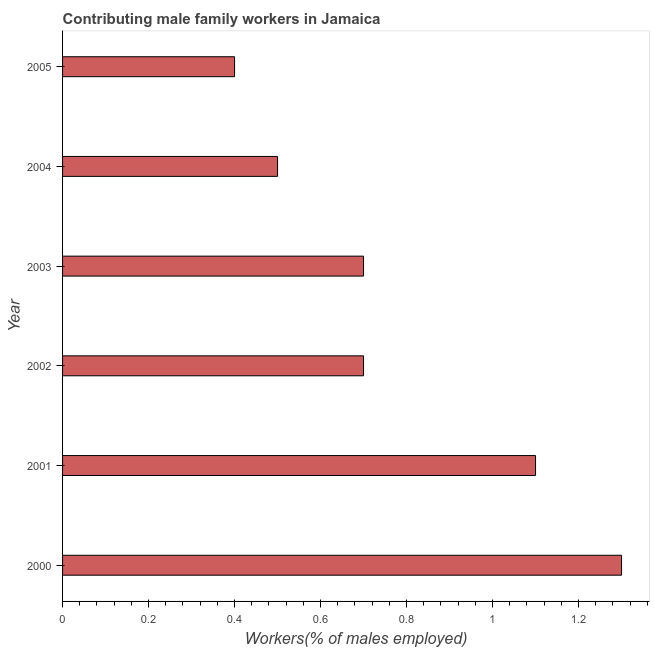What is the title of the graph?
Your answer should be very brief. Contributing male family workers in Jamaica. What is the label or title of the X-axis?
Ensure brevity in your answer.  Workers(% of males employed). What is the label or title of the Y-axis?
Give a very brief answer. Year. What is the contributing male family workers in 2002?
Give a very brief answer. 0.7. Across all years, what is the maximum contributing male family workers?
Offer a terse response. 1.3. Across all years, what is the minimum contributing male family workers?
Your response must be concise. 0.4. In which year was the contributing male family workers minimum?
Offer a terse response. 2005. What is the sum of the contributing male family workers?
Your answer should be very brief. 4.7. What is the average contributing male family workers per year?
Ensure brevity in your answer.  0.78. What is the median contributing male family workers?
Your answer should be compact. 0.7. What is the difference between two consecutive major ticks on the X-axis?
Make the answer very short. 0.2. Are the values on the major ticks of X-axis written in scientific E-notation?
Your answer should be compact. No. What is the Workers(% of males employed) of 2000?
Your answer should be very brief. 1.3. What is the Workers(% of males employed) of 2001?
Your answer should be compact. 1.1. What is the Workers(% of males employed) of 2002?
Offer a terse response. 0.7. What is the Workers(% of males employed) of 2003?
Offer a terse response. 0.7. What is the Workers(% of males employed) of 2004?
Provide a short and direct response. 0.5. What is the Workers(% of males employed) of 2005?
Give a very brief answer. 0.4. What is the difference between the Workers(% of males employed) in 2000 and 2004?
Offer a terse response. 0.8. What is the difference between the Workers(% of males employed) in 2001 and 2003?
Offer a terse response. 0.4. What is the difference between the Workers(% of males employed) in 2002 and 2004?
Make the answer very short. 0.2. What is the difference between the Workers(% of males employed) in 2003 and 2004?
Ensure brevity in your answer.  0.2. What is the difference between the Workers(% of males employed) in 2003 and 2005?
Keep it short and to the point. 0.3. What is the difference between the Workers(% of males employed) in 2004 and 2005?
Offer a very short reply. 0.1. What is the ratio of the Workers(% of males employed) in 2000 to that in 2001?
Offer a terse response. 1.18. What is the ratio of the Workers(% of males employed) in 2000 to that in 2002?
Your response must be concise. 1.86. What is the ratio of the Workers(% of males employed) in 2000 to that in 2003?
Offer a terse response. 1.86. What is the ratio of the Workers(% of males employed) in 2000 to that in 2004?
Ensure brevity in your answer.  2.6. What is the ratio of the Workers(% of males employed) in 2000 to that in 2005?
Your answer should be very brief. 3.25. What is the ratio of the Workers(% of males employed) in 2001 to that in 2002?
Ensure brevity in your answer.  1.57. What is the ratio of the Workers(% of males employed) in 2001 to that in 2003?
Ensure brevity in your answer.  1.57. What is the ratio of the Workers(% of males employed) in 2001 to that in 2005?
Provide a short and direct response. 2.75. What is the ratio of the Workers(% of males employed) in 2003 to that in 2004?
Make the answer very short. 1.4. What is the ratio of the Workers(% of males employed) in 2004 to that in 2005?
Your response must be concise. 1.25. 